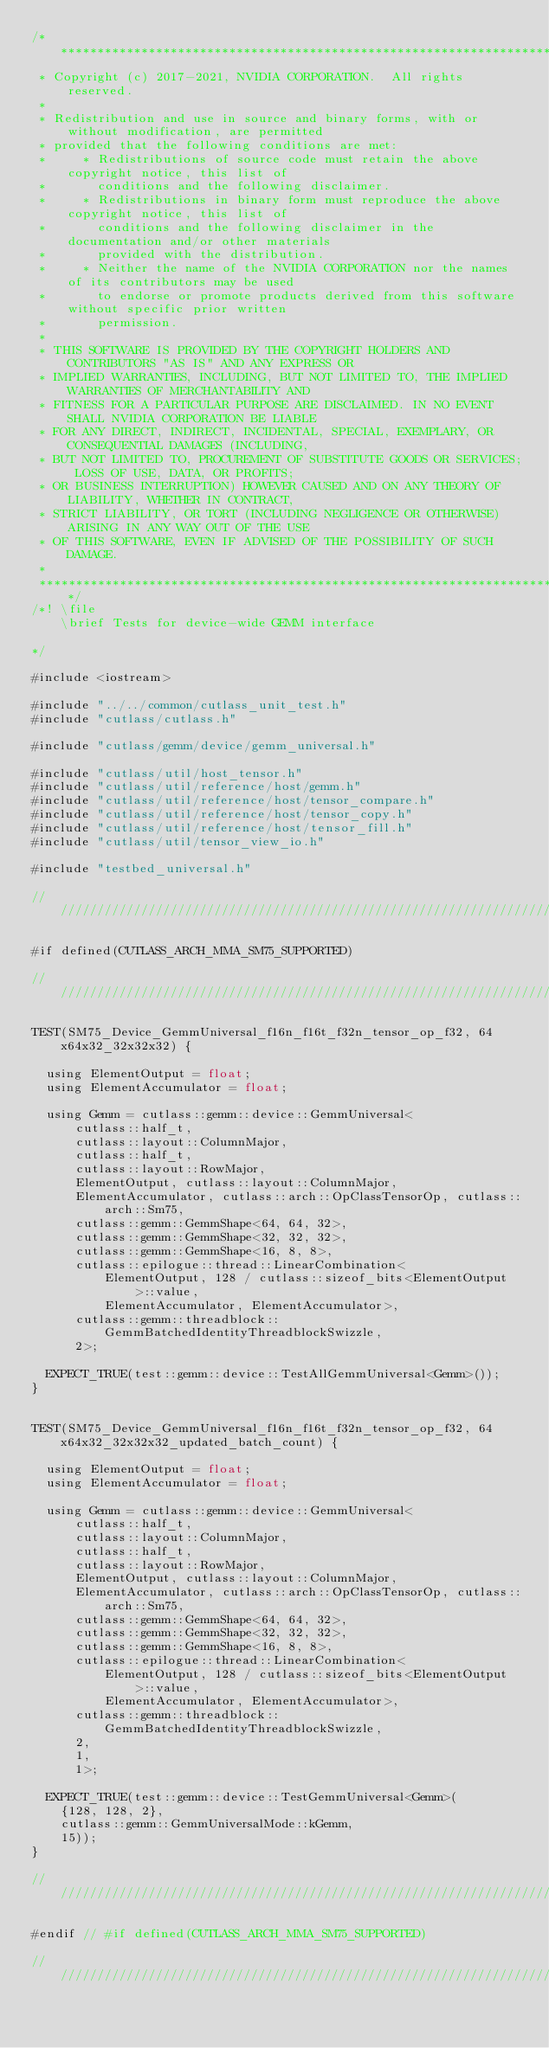<code> <loc_0><loc_0><loc_500><loc_500><_Cuda_>/***************************************************************************************************
 * Copyright (c) 2017-2021, NVIDIA CORPORATION.  All rights reserved.
 *
 * Redistribution and use in source and binary forms, with or without modification, are permitted
 * provided that the following conditions are met:
 *     * Redistributions of source code must retain the above copyright notice, this list of
 *       conditions and the following disclaimer.
 *     * Redistributions in binary form must reproduce the above copyright notice, this list of
 *       conditions and the following disclaimer in the documentation and/or other materials
 *       provided with the distribution.
 *     * Neither the name of the NVIDIA CORPORATION nor the names of its contributors may be used
 *       to endorse or promote products derived from this software without specific prior written
 *       permission.
 *
 * THIS SOFTWARE IS PROVIDED BY THE COPYRIGHT HOLDERS AND CONTRIBUTORS "AS IS" AND ANY EXPRESS OR
 * IMPLIED WARRANTIES, INCLUDING, BUT NOT LIMITED TO, THE IMPLIED WARRANTIES OF MERCHANTABILITY AND
 * FITNESS FOR A PARTICULAR PURPOSE ARE DISCLAIMED. IN NO EVENT SHALL NVIDIA CORPORATION BE LIABLE
 * FOR ANY DIRECT, INDIRECT, INCIDENTAL, SPECIAL, EXEMPLARY, OR CONSEQUENTIAL DAMAGES (INCLUDING,
 * BUT NOT LIMITED TO, PROCUREMENT OF SUBSTITUTE GOODS OR SERVICES; LOSS OF USE, DATA, OR PROFITS;
 * OR BUSINESS INTERRUPTION) HOWEVER CAUSED AND ON ANY THEORY OF LIABILITY, WHETHER IN CONTRACT,
 * STRICT LIABILITY, OR TORT (INCLUDING NEGLIGENCE OR OTHERWISE) ARISING IN ANY WAY OUT OF THE USE
 * OF THIS SOFTWARE, EVEN IF ADVISED OF THE POSSIBILITY OF SUCH DAMAGE.
 *
 **************************************************************************************************/
/*! \file
    \brief Tests for device-wide GEMM interface
    
*/

#include <iostream>

#include "../../common/cutlass_unit_test.h"
#include "cutlass/cutlass.h"

#include "cutlass/gemm/device/gemm_universal.h"

#include "cutlass/util/host_tensor.h"
#include "cutlass/util/reference/host/gemm.h"
#include "cutlass/util/reference/host/tensor_compare.h"
#include "cutlass/util/reference/host/tensor_copy.h"
#include "cutlass/util/reference/host/tensor_fill.h"
#include "cutlass/util/tensor_view_io.h"

#include "testbed_universal.h"

////////////////////////////////////////////////////////////////////////////////

#if defined(CUTLASS_ARCH_MMA_SM75_SUPPORTED)

////////////////////////////////////////////////////////////////////////////////

TEST(SM75_Device_GemmUniversal_f16n_f16t_f32n_tensor_op_f32, 64x64x32_32x32x32) {

  using ElementOutput = float;
  using ElementAccumulator = float;

  using Gemm = cutlass::gemm::device::GemmUniversal<
      cutlass::half_t, 
      cutlass::layout::ColumnMajor, 
      cutlass::half_t,
      cutlass::layout::RowMajor, 
      ElementOutput, cutlass::layout::ColumnMajor,
      ElementAccumulator, cutlass::arch::OpClassTensorOp, cutlass::arch::Sm75,
      cutlass::gemm::GemmShape<64, 64, 32>,
      cutlass::gemm::GemmShape<32, 32, 32>, 
      cutlass::gemm::GemmShape<16, 8, 8>,
      cutlass::epilogue::thread::LinearCombination<
          ElementOutput, 128 / cutlass::sizeof_bits<ElementOutput>::value,
          ElementAccumulator, ElementAccumulator>,
      cutlass::gemm::threadblock::GemmBatchedIdentityThreadblockSwizzle, 
      2>;

  EXPECT_TRUE(test::gemm::device::TestAllGemmUniversal<Gemm>());
}


TEST(SM75_Device_GemmUniversal_f16n_f16t_f32n_tensor_op_f32, 64x64x32_32x32x32_updated_batch_count) {

  using ElementOutput = float;
  using ElementAccumulator = float;

  using Gemm = cutlass::gemm::device::GemmUniversal<
      cutlass::half_t, 
      cutlass::layout::ColumnMajor, 
      cutlass::half_t,
      cutlass::layout::RowMajor, 
      ElementOutput, cutlass::layout::ColumnMajor,
      ElementAccumulator, cutlass::arch::OpClassTensorOp, cutlass::arch::Sm75,
      cutlass::gemm::GemmShape<64, 64, 32>,
      cutlass::gemm::GemmShape<32, 32, 32>, 
      cutlass::gemm::GemmShape<16, 8, 8>,
      cutlass::epilogue::thread::LinearCombination<
          ElementOutput, 128 / cutlass::sizeof_bits<ElementOutput>::value,
          ElementAccumulator, ElementAccumulator>,
      cutlass::gemm::threadblock::GemmBatchedIdentityThreadblockSwizzle, 
      2,
      1,
      1>;

  EXPECT_TRUE(test::gemm::device::TestGemmUniversal<Gemm>(
    {128, 128, 2}, 
    cutlass::gemm::GemmUniversalMode::kGemm, 
    15));
}

////////////////////////////////////////////////////////////////////////////////

#endif // #if defined(CUTLASS_ARCH_MMA_SM75_SUPPORTED)

////////////////////////////////////////////////////////////////////////////////

</code> 